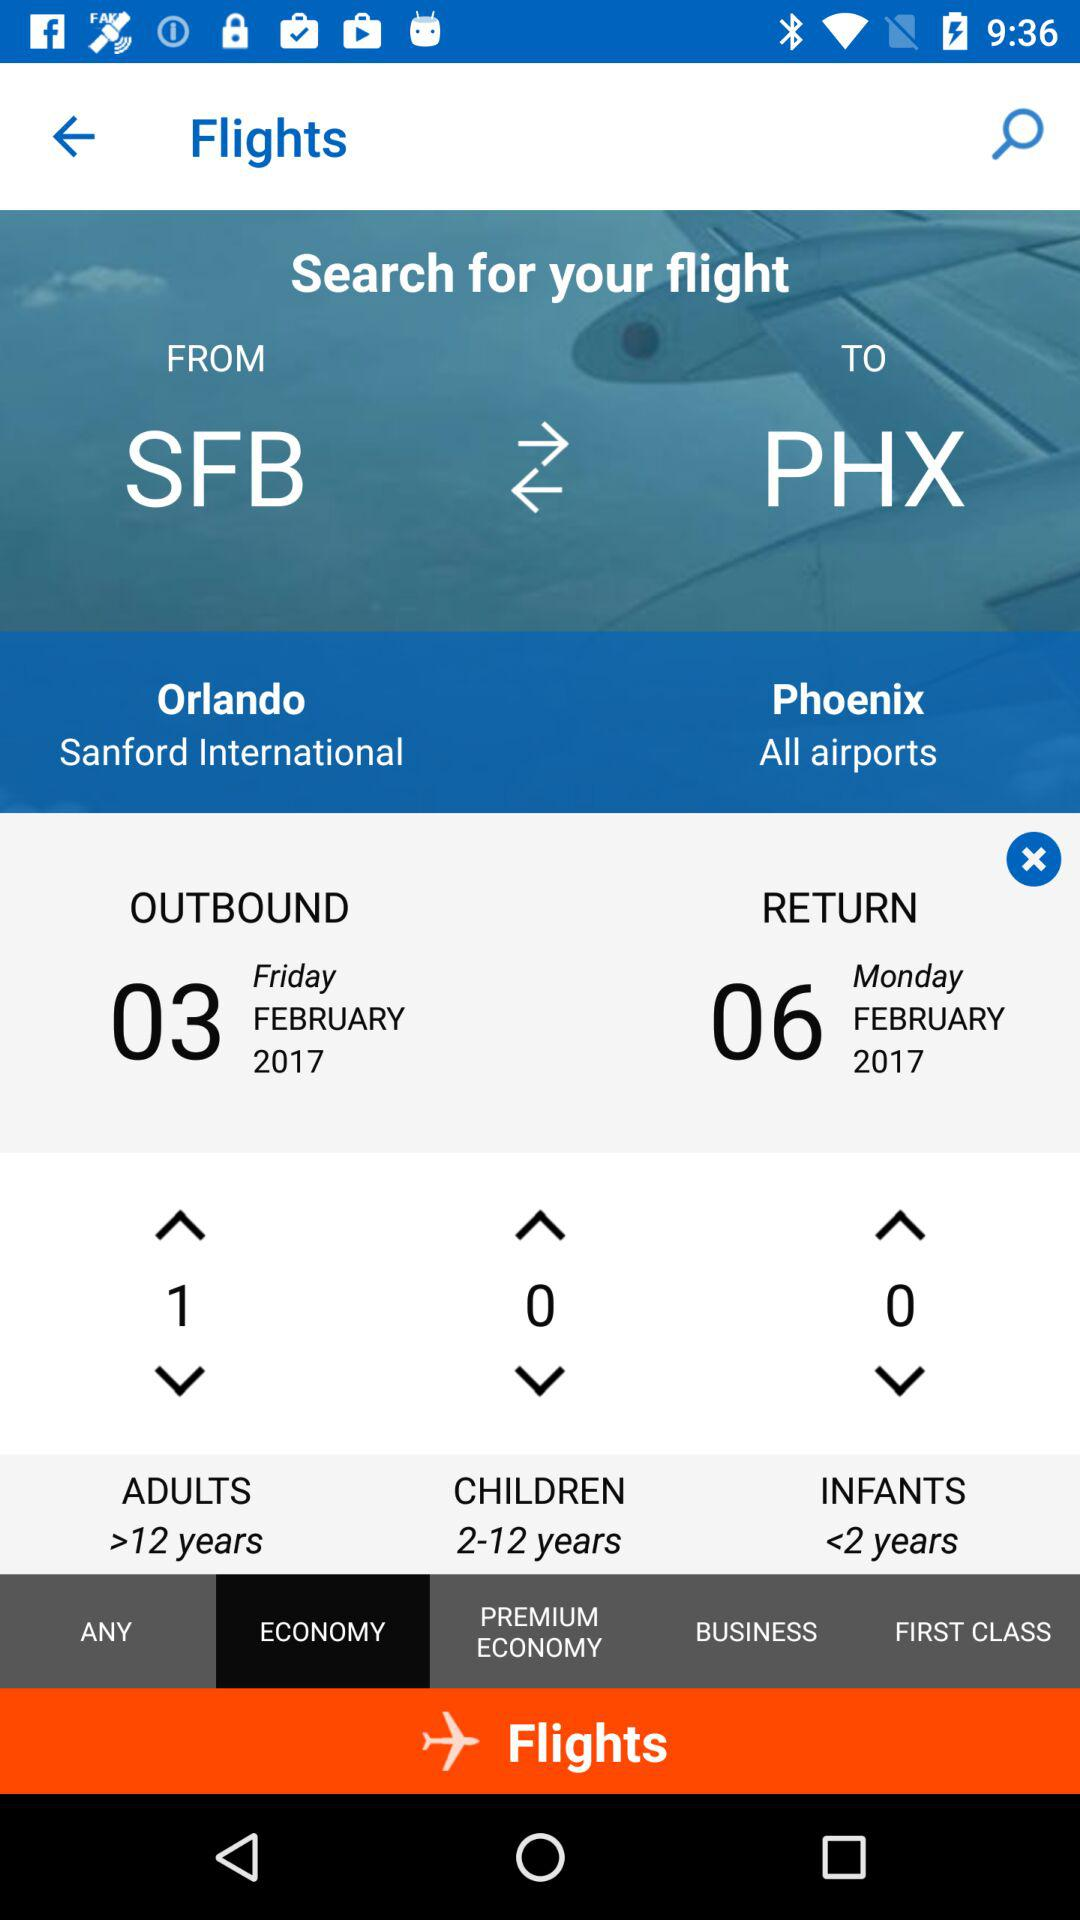What is the departure city name? The departure city name is Orlando. 